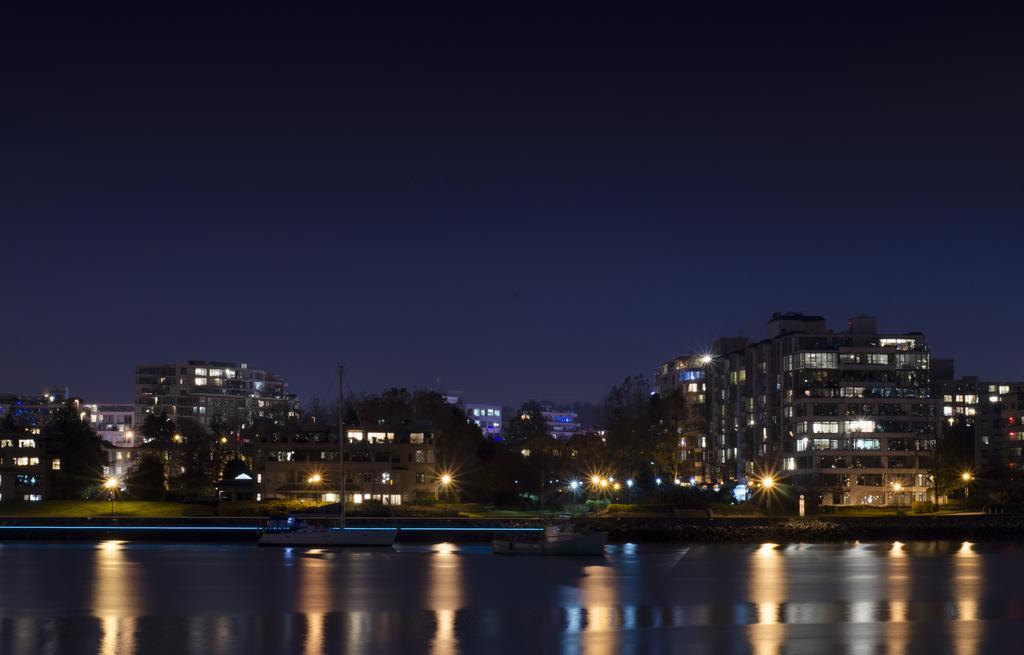Please provide a concise description of this image. In this picture I can see buildings, street lights and water. In the background I can see the sky. 